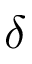<formula> <loc_0><loc_0><loc_500><loc_500>\delta</formula> 